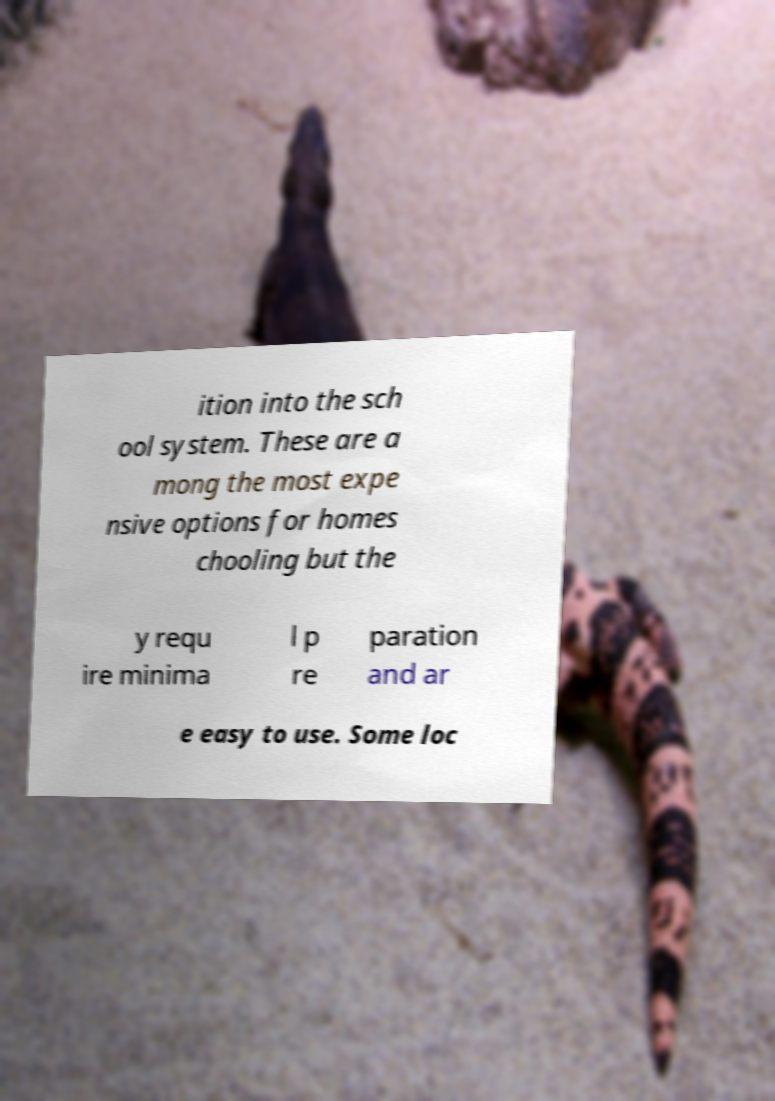Please read and relay the text visible in this image. What does it say? ition into the sch ool system. These are a mong the most expe nsive options for homes chooling but the y requ ire minima l p re paration and ar e easy to use. Some loc 